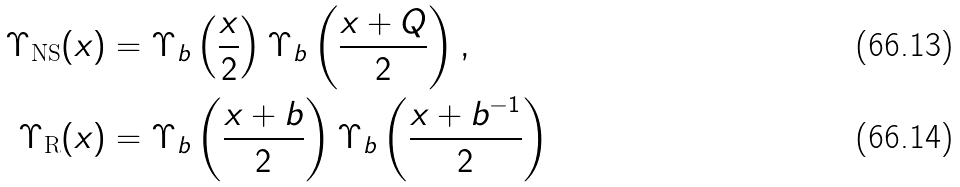<formula> <loc_0><loc_0><loc_500><loc_500>\Upsilon _ { \text {NS} } ( x ) & = \Upsilon _ { b } \left ( \frac { x } { 2 } \right ) \Upsilon _ { b } \left ( \frac { x + Q } 2 \right ) , \\ \Upsilon _ { \text {R} } ( x ) & = \Upsilon _ { b } \left ( \frac { x + b } 2 \right ) \Upsilon _ { b } \left ( \frac { x + b ^ { - 1 } } 2 \right )</formula> 